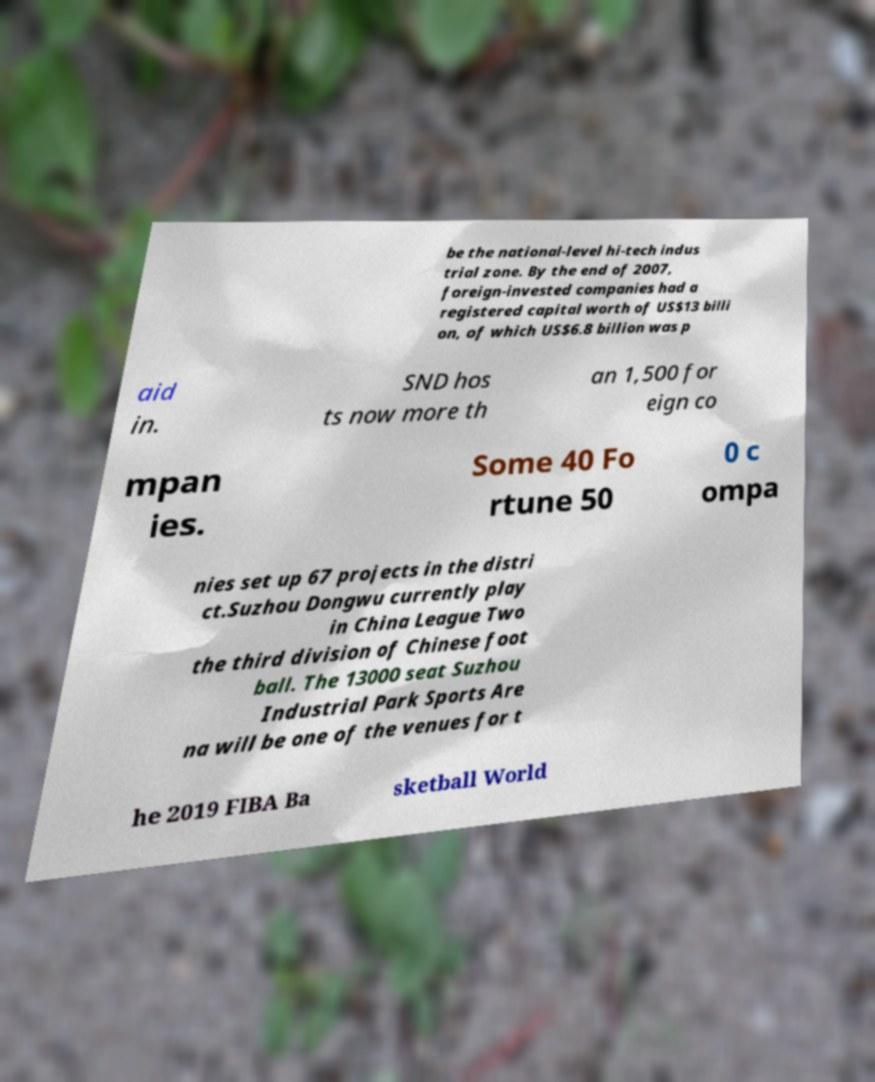Could you extract and type out the text from this image? be the national-level hi-tech indus trial zone. By the end of 2007, foreign-invested companies had a registered capital worth of US$13 billi on, of which US$6.8 billion was p aid in. SND hos ts now more th an 1,500 for eign co mpan ies. Some 40 Fo rtune 50 0 c ompa nies set up 67 projects in the distri ct.Suzhou Dongwu currently play in China League Two the third division of Chinese foot ball. The 13000 seat Suzhou Industrial Park Sports Are na will be one of the venues for t he 2019 FIBA Ba sketball World 